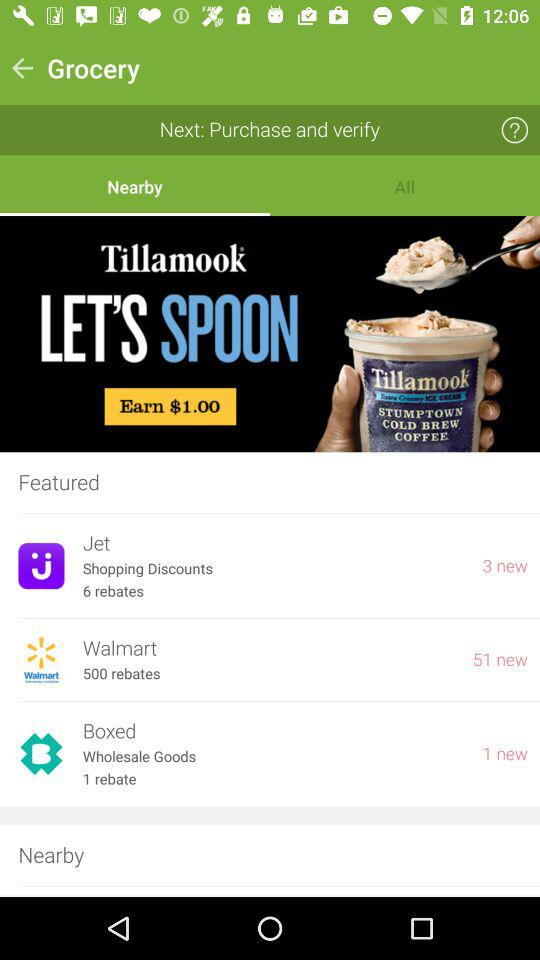Which tab is selected? The selected tab is "Nearby". 